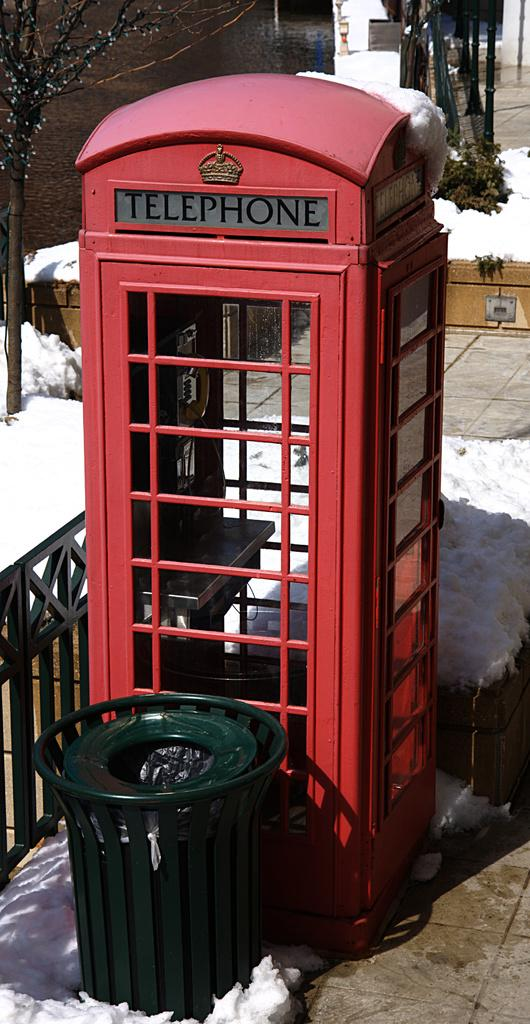What type of structure is present in the image? There is a telephone booth in the image. What else can be seen in the image besides the telephone booth? There is a garbage bin, a fence, snow, a footpath, a plant, and a tree in the image. What might be used for disposing of waste in the image? The garbage bin can be used for disposing of waste in the image. What type of vegetation is present in the image? There is a plant and a tree in the image. What type of dinner is being served in the image? There is no dinner present in the image; it features a telephone booth, garbage bin, fence, snow, footpath, plant, and tree. Is there any indication of a birth occurring in the image? There is no indication of a birth occurring in the image. 